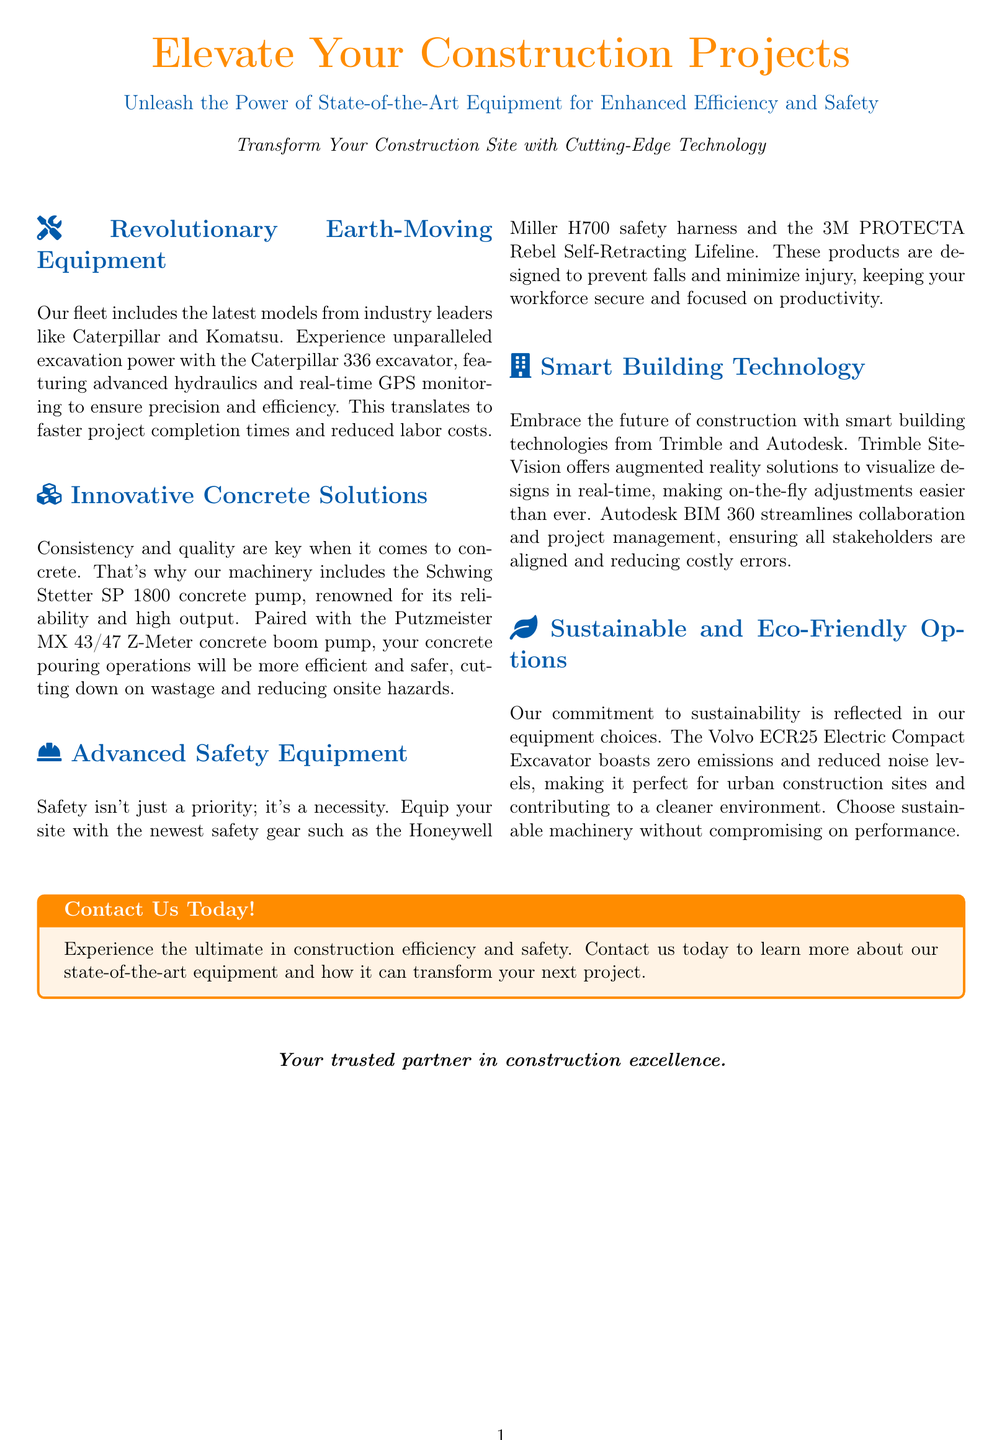What is the color associated with the advertisement title? The advertisement uses the color orange in the title.
Answer: orange Which company produces the excavator mentioned? The document states that the Caterpillar 336 excavator is from Caterpillar.
Answer: Caterpillar What is the model of the concrete pump listed? The concrete pump mentioned is the Schwing Stetter SP 1800.
Answer: Schwing Stetter SP 1800 What safety equipment is highlighted in the advertisement? The advertisement highlights the Honeywell Miller H700 safety harness.
Answer: Honeywell Miller H700 What technology does Trimble SiteVision use? Trimble SiteVision offers augmented reality solutions.
Answer: augmented reality How does the Volvo ECR25 Electric Compact Excavator contribute to the environment? The Volvo ECR25 has zero emissions.
Answer: zero emissions What benefit does real-time GPS monitoring provide? Real-time GPS monitoring ensures precision and efficiency in excavation.
Answer: precision and efficiency Which brand provides the self-retracting lifeline mentioned? The self-retracting lifeline is from 3M.
Answer: 3M What is the main goal of using state-of-the-art equipment according to the document? The main goal is to enhance efficiency and safety in construction projects.
Answer: enhance efficiency and safety 